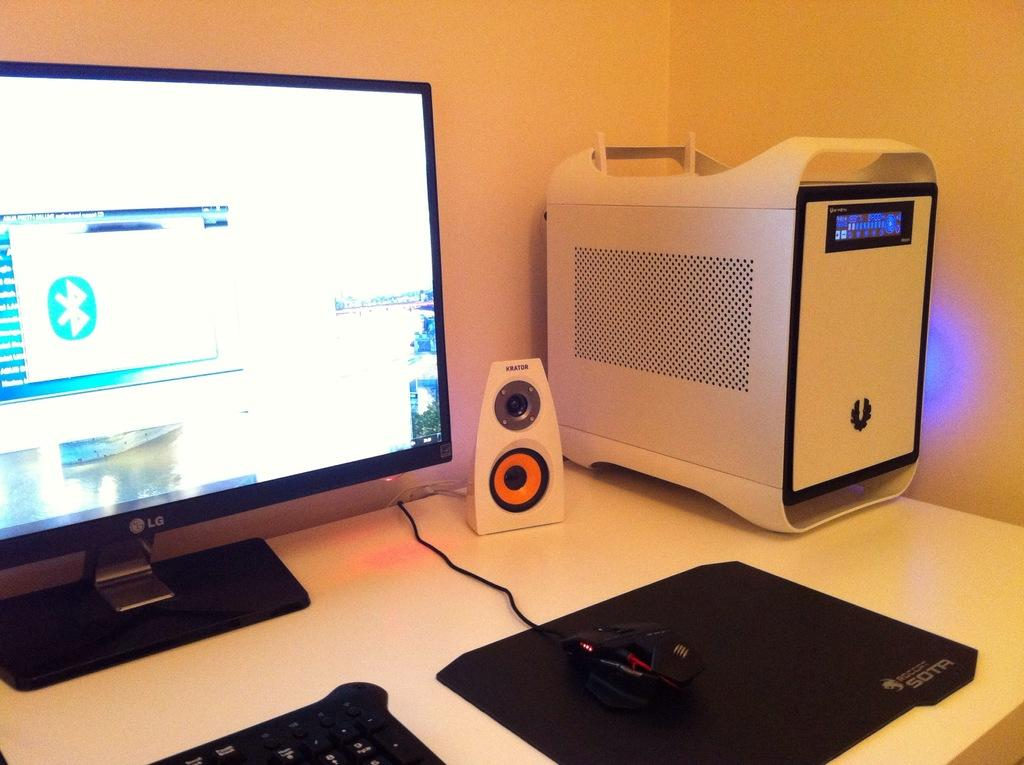<image>
Give a short and clear explanation of the subsequent image. A computer set up that includes the hard drive, a large display screen, and a speaker made by Krator. 